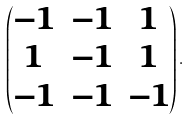Convert formula to latex. <formula><loc_0><loc_0><loc_500><loc_500>\begin{pmatrix} - 1 & - 1 & 1 \\ 1 & - 1 & 1 \\ - 1 & - 1 & - 1 \\ \end{pmatrix} .</formula> 